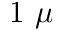<formula> <loc_0><loc_0><loc_500><loc_500>1 \mu</formula> 